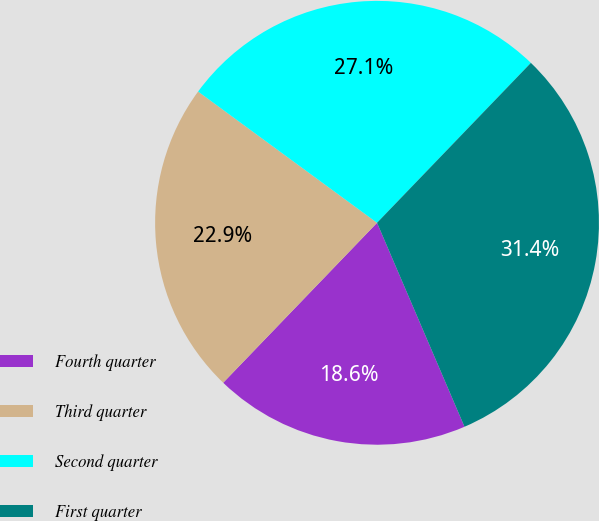<chart> <loc_0><loc_0><loc_500><loc_500><pie_chart><fcel>Fourth quarter<fcel>Third quarter<fcel>Second quarter<fcel>First quarter<nl><fcel>18.64%<fcel>22.88%<fcel>27.12%<fcel>31.36%<nl></chart> 